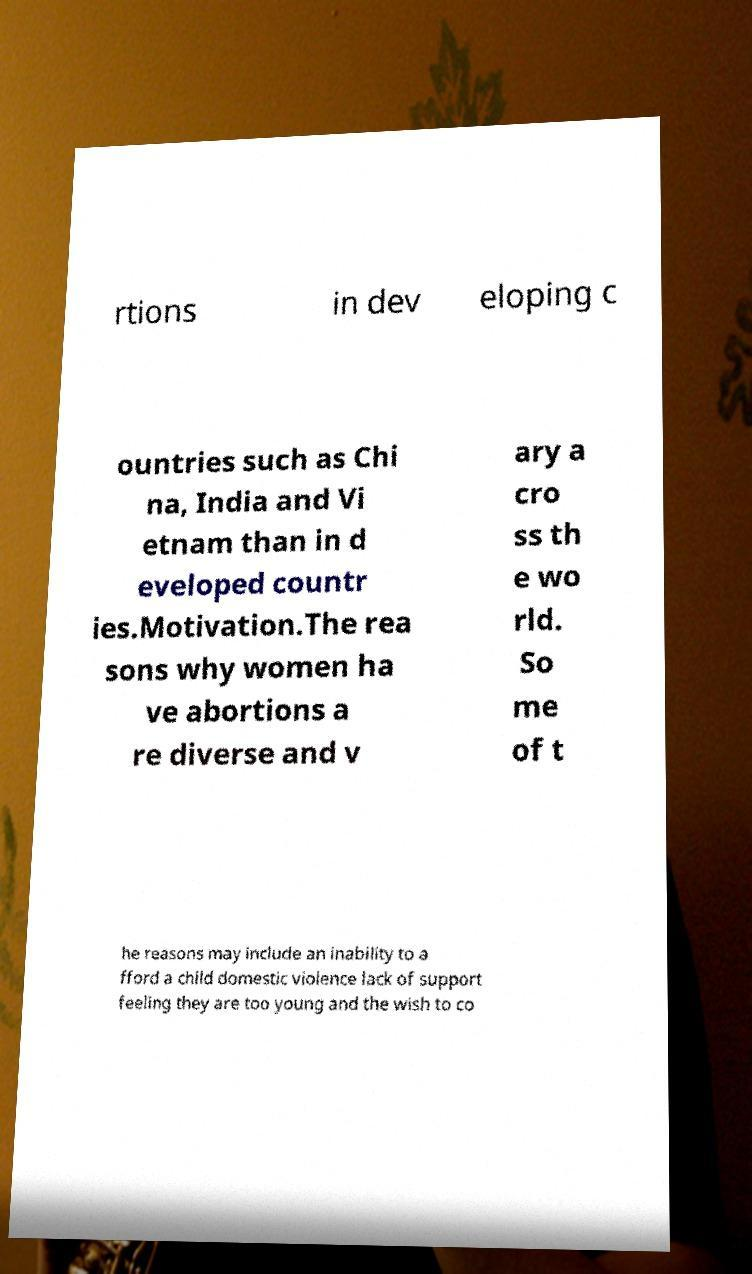Could you extract and type out the text from this image? rtions in dev eloping c ountries such as Chi na, India and Vi etnam than in d eveloped countr ies.Motivation.The rea sons why women ha ve abortions a re diverse and v ary a cro ss th e wo rld. So me of t he reasons may include an inability to a fford a child domestic violence lack of support feeling they are too young and the wish to co 